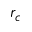Convert formula to latex. <formula><loc_0><loc_0><loc_500><loc_500>r _ { c }</formula> 